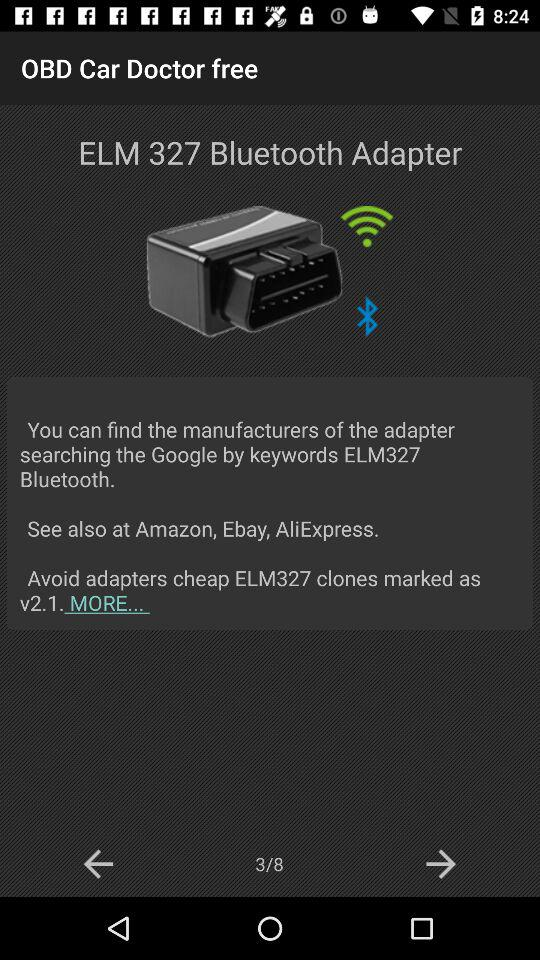How can I find the manufacturers of the adapters?
Answer the question using a single word or phrase. You can find the manufacturers of the adapters by searching "Google" with the keywords "ELM327 Bluetooth." 